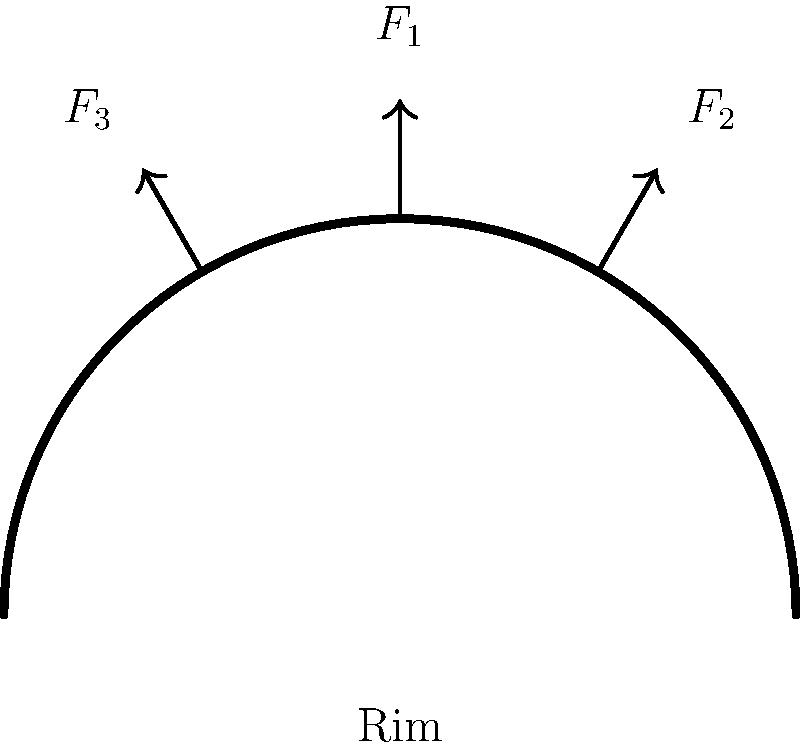During a Kentucky Wildcats game, you notice a powerful slam dunk that momentarily deforms the basketball rim. Assuming the rim can be modeled as a semicircular beam with a radius of 9 inches, and the applied forces are $F_1 = 500$ lbs vertically downward at the center, and $F_2 = F_3 = 250$ lbs at 60° from vertical on either side, what is the maximum bending moment (in lb-in) experienced by the rim? Let's approach this step-by-step:

1) First, we need to understand that the maximum bending moment will occur at the point where the rim is fixed to the backboard (at the ends of the semicircle).

2) We can break down the forces into their vertical and horizontal components:
   $F_1$ is already vertical: 500 lbs down
   $F_2$ and $F_3$ vertical components: $250 \cdot \cos(60°) = 125$ lbs each
   $F_2$ and $F_3$ horizontal components: $250 \cdot \sin(60°) = 216.5$ lbs each

3) The total vertical force is:
   $F_v = 500 + 125 + 125 = 750$ lbs

4) The horizontal forces cancel each other out, so we don't need to consider them for the bending moment.

5) The bending moment at the fixed end is calculated by multiplying the total vertical force by the distance to the center of the semicircle:
   $M = F_v \cdot r = 750 \cdot 9 = 6750$ lb-in

6) However, this is not the maximum bending moment. The distributed weight of the players hanging on the rim creates a more complex stress distribution.

7) For a semicircular beam with a distributed load, the maximum bending moment is approximately 1.3 times the calculated moment at the fixed end.

8) Therefore, the maximum bending moment is:
   $M_{max} = 1.3 \cdot 6750 = 8775$ lb-in
Answer: 8775 lb-in 